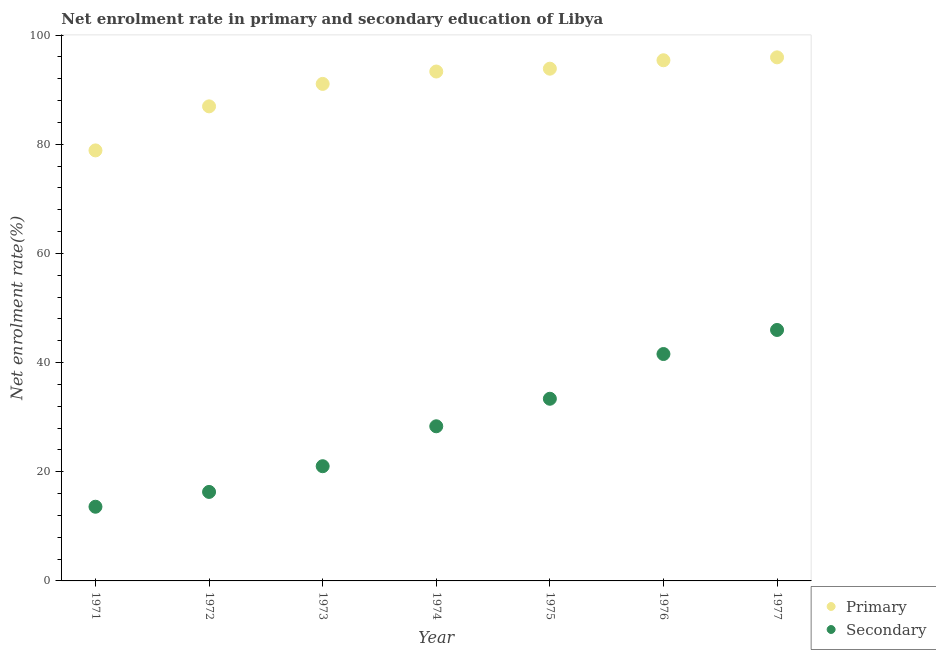How many different coloured dotlines are there?
Your response must be concise. 2. What is the enrollment rate in primary education in 1977?
Make the answer very short. 95.93. Across all years, what is the maximum enrollment rate in primary education?
Ensure brevity in your answer.  95.93. Across all years, what is the minimum enrollment rate in primary education?
Keep it short and to the point. 78.88. What is the total enrollment rate in secondary education in the graph?
Your response must be concise. 200.18. What is the difference between the enrollment rate in primary education in 1971 and that in 1973?
Your answer should be compact. -12.18. What is the difference between the enrollment rate in primary education in 1972 and the enrollment rate in secondary education in 1973?
Provide a succinct answer. 65.94. What is the average enrollment rate in secondary education per year?
Provide a short and direct response. 28.6. In the year 1972, what is the difference between the enrollment rate in secondary education and enrollment rate in primary education?
Offer a terse response. -70.65. What is the ratio of the enrollment rate in primary education in 1973 to that in 1977?
Keep it short and to the point. 0.95. Is the enrollment rate in secondary education in 1971 less than that in 1977?
Make the answer very short. Yes. What is the difference between the highest and the second highest enrollment rate in primary education?
Provide a short and direct response. 0.54. What is the difference between the highest and the lowest enrollment rate in secondary education?
Provide a short and direct response. 32.39. Is the sum of the enrollment rate in secondary education in 1973 and 1977 greater than the maximum enrollment rate in primary education across all years?
Keep it short and to the point. No. Is the enrollment rate in primary education strictly less than the enrollment rate in secondary education over the years?
Your answer should be compact. No. How many dotlines are there?
Your answer should be very brief. 2. Are the values on the major ticks of Y-axis written in scientific E-notation?
Offer a terse response. No. Where does the legend appear in the graph?
Ensure brevity in your answer.  Bottom right. How many legend labels are there?
Your answer should be compact. 2. What is the title of the graph?
Offer a very short reply. Net enrolment rate in primary and secondary education of Libya. Does "Females" appear as one of the legend labels in the graph?
Offer a very short reply. No. What is the label or title of the Y-axis?
Your response must be concise. Net enrolment rate(%). What is the Net enrolment rate(%) in Primary in 1971?
Ensure brevity in your answer.  78.88. What is the Net enrolment rate(%) of Secondary in 1971?
Your response must be concise. 13.59. What is the Net enrolment rate(%) of Primary in 1972?
Your answer should be compact. 86.95. What is the Net enrolment rate(%) in Secondary in 1972?
Offer a very short reply. 16.31. What is the Net enrolment rate(%) of Primary in 1973?
Offer a very short reply. 91.07. What is the Net enrolment rate(%) of Secondary in 1973?
Ensure brevity in your answer.  21.02. What is the Net enrolment rate(%) of Primary in 1974?
Provide a succinct answer. 93.34. What is the Net enrolment rate(%) in Secondary in 1974?
Provide a short and direct response. 28.33. What is the Net enrolment rate(%) of Primary in 1975?
Offer a terse response. 93.86. What is the Net enrolment rate(%) in Secondary in 1975?
Offer a terse response. 33.38. What is the Net enrolment rate(%) in Primary in 1976?
Your answer should be very brief. 95.4. What is the Net enrolment rate(%) in Secondary in 1976?
Keep it short and to the point. 41.57. What is the Net enrolment rate(%) in Primary in 1977?
Offer a very short reply. 95.93. What is the Net enrolment rate(%) of Secondary in 1977?
Offer a terse response. 45.98. Across all years, what is the maximum Net enrolment rate(%) in Primary?
Your answer should be compact. 95.93. Across all years, what is the maximum Net enrolment rate(%) of Secondary?
Offer a terse response. 45.98. Across all years, what is the minimum Net enrolment rate(%) of Primary?
Offer a terse response. 78.88. Across all years, what is the minimum Net enrolment rate(%) in Secondary?
Offer a terse response. 13.59. What is the total Net enrolment rate(%) of Primary in the graph?
Offer a terse response. 635.42. What is the total Net enrolment rate(%) in Secondary in the graph?
Your answer should be compact. 200.18. What is the difference between the Net enrolment rate(%) of Primary in 1971 and that in 1972?
Give a very brief answer. -8.07. What is the difference between the Net enrolment rate(%) in Secondary in 1971 and that in 1972?
Your answer should be compact. -2.71. What is the difference between the Net enrolment rate(%) in Primary in 1971 and that in 1973?
Provide a short and direct response. -12.18. What is the difference between the Net enrolment rate(%) in Secondary in 1971 and that in 1973?
Your answer should be compact. -7.43. What is the difference between the Net enrolment rate(%) of Primary in 1971 and that in 1974?
Your answer should be compact. -14.45. What is the difference between the Net enrolment rate(%) in Secondary in 1971 and that in 1974?
Provide a short and direct response. -14.74. What is the difference between the Net enrolment rate(%) in Primary in 1971 and that in 1975?
Offer a very short reply. -14.97. What is the difference between the Net enrolment rate(%) in Secondary in 1971 and that in 1975?
Your response must be concise. -19.78. What is the difference between the Net enrolment rate(%) in Primary in 1971 and that in 1976?
Make the answer very short. -16.51. What is the difference between the Net enrolment rate(%) of Secondary in 1971 and that in 1976?
Provide a succinct answer. -27.98. What is the difference between the Net enrolment rate(%) of Primary in 1971 and that in 1977?
Make the answer very short. -17.05. What is the difference between the Net enrolment rate(%) of Secondary in 1971 and that in 1977?
Provide a succinct answer. -32.39. What is the difference between the Net enrolment rate(%) in Primary in 1972 and that in 1973?
Keep it short and to the point. -4.11. What is the difference between the Net enrolment rate(%) in Secondary in 1972 and that in 1973?
Provide a short and direct response. -4.71. What is the difference between the Net enrolment rate(%) of Primary in 1972 and that in 1974?
Your answer should be compact. -6.38. What is the difference between the Net enrolment rate(%) of Secondary in 1972 and that in 1974?
Keep it short and to the point. -12.03. What is the difference between the Net enrolment rate(%) of Primary in 1972 and that in 1975?
Offer a very short reply. -6.9. What is the difference between the Net enrolment rate(%) in Secondary in 1972 and that in 1975?
Offer a terse response. -17.07. What is the difference between the Net enrolment rate(%) in Primary in 1972 and that in 1976?
Provide a succinct answer. -8.44. What is the difference between the Net enrolment rate(%) of Secondary in 1972 and that in 1976?
Provide a short and direct response. -25.27. What is the difference between the Net enrolment rate(%) in Primary in 1972 and that in 1977?
Make the answer very short. -8.98. What is the difference between the Net enrolment rate(%) of Secondary in 1972 and that in 1977?
Provide a short and direct response. -29.68. What is the difference between the Net enrolment rate(%) of Primary in 1973 and that in 1974?
Keep it short and to the point. -2.27. What is the difference between the Net enrolment rate(%) of Secondary in 1973 and that in 1974?
Your response must be concise. -7.32. What is the difference between the Net enrolment rate(%) of Primary in 1973 and that in 1975?
Your answer should be very brief. -2.79. What is the difference between the Net enrolment rate(%) of Secondary in 1973 and that in 1975?
Keep it short and to the point. -12.36. What is the difference between the Net enrolment rate(%) in Primary in 1973 and that in 1976?
Offer a terse response. -4.33. What is the difference between the Net enrolment rate(%) of Secondary in 1973 and that in 1976?
Your answer should be very brief. -20.56. What is the difference between the Net enrolment rate(%) in Primary in 1973 and that in 1977?
Offer a very short reply. -4.87. What is the difference between the Net enrolment rate(%) of Secondary in 1973 and that in 1977?
Provide a short and direct response. -24.96. What is the difference between the Net enrolment rate(%) of Primary in 1974 and that in 1975?
Your response must be concise. -0.52. What is the difference between the Net enrolment rate(%) in Secondary in 1974 and that in 1975?
Make the answer very short. -5.04. What is the difference between the Net enrolment rate(%) in Primary in 1974 and that in 1976?
Your answer should be very brief. -2.06. What is the difference between the Net enrolment rate(%) of Secondary in 1974 and that in 1976?
Provide a succinct answer. -13.24. What is the difference between the Net enrolment rate(%) of Primary in 1974 and that in 1977?
Your answer should be very brief. -2.6. What is the difference between the Net enrolment rate(%) in Secondary in 1974 and that in 1977?
Give a very brief answer. -17.65. What is the difference between the Net enrolment rate(%) in Primary in 1975 and that in 1976?
Provide a succinct answer. -1.54. What is the difference between the Net enrolment rate(%) of Secondary in 1975 and that in 1976?
Provide a short and direct response. -8.2. What is the difference between the Net enrolment rate(%) of Primary in 1975 and that in 1977?
Your answer should be very brief. -2.08. What is the difference between the Net enrolment rate(%) of Secondary in 1975 and that in 1977?
Your answer should be very brief. -12.6. What is the difference between the Net enrolment rate(%) of Primary in 1976 and that in 1977?
Offer a very short reply. -0.54. What is the difference between the Net enrolment rate(%) of Secondary in 1976 and that in 1977?
Make the answer very short. -4.41. What is the difference between the Net enrolment rate(%) of Primary in 1971 and the Net enrolment rate(%) of Secondary in 1972?
Provide a succinct answer. 62.58. What is the difference between the Net enrolment rate(%) in Primary in 1971 and the Net enrolment rate(%) in Secondary in 1973?
Provide a succinct answer. 57.87. What is the difference between the Net enrolment rate(%) in Primary in 1971 and the Net enrolment rate(%) in Secondary in 1974?
Your answer should be compact. 50.55. What is the difference between the Net enrolment rate(%) of Primary in 1971 and the Net enrolment rate(%) of Secondary in 1975?
Your answer should be compact. 45.51. What is the difference between the Net enrolment rate(%) in Primary in 1971 and the Net enrolment rate(%) in Secondary in 1976?
Keep it short and to the point. 37.31. What is the difference between the Net enrolment rate(%) of Primary in 1971 and the Net enrolment rate(%) of Secondary in 1977?
Your answer should be very brief. 32.9. What is the difference between the Net enrolment rate(%) in Primary in 1972 and the Net enrolment rate(%) in Secondary in 1973?
Your answer should be very brief. 65.94. What is the difference between the Net enrolment rate(%) in Primary in 1972 and the Net enrolment rate(%) in Secondary in 1974?
Your response must be concise. 58.62. What is the difference between the Net enrolment rate(%) in Primary in 1972 and the Net enrolment rate(%) in Secondary in 1975?
Your answer should be compact. 53.58. What is the difference between the Net enrolment rate(%) in Primary in 1972 and the Net enrolment rate(%) in Secondary in 1976?
Your response must be concise. 45.38. What is the difference between the Net enrolment rate(%) in Primary in 1972 and the Net enrolment rate(%) in Secondary in 1977?
Offer a terse response. 40.97. What is the difference between the Net enrolment rate(%) in Primary in 1973 and the Net enrolment rate(%) in Secondary in 1974?
Offer a terse response. 62.73. What is the difference between the Net enrolment rate(%) in Primary in 1973 and the Net enrolment rate(%) in Secondary in 1975?
Your response must be concise. 57.69. What is the difference between the Net enrolment rate(%) in Primary in 1973 and the Net enrolment rate(%) in Secondary in 1976?
Offer a very short reply. 49.49. What is the difference between the Net enrolment rate(%) of Primary in 1973 and the Net enrolment rate(%) of Secondary in 1977?
Ensure brevity in your answer.  45.08. What is the difference between the Net enrolment rate(%) of Primary in 1974 and the Net enrolment rate(%) of Secondary in 1975?
Provide a succinct answer. 59.96. What is the difference between the Net enrolment rate(%) of Primary in 1974 and the Net enrolment rate(%) of Secondary in 1976?
Your answer should be compact. 51.76. What is the difference between the Net enrolment rate(%) of Primary in 1974 and the Net enrolment rate(%) of Secondary in 1977?
Your answer should be compact. 47.35. What is the difference between the Net enrolment rate(%) in Primary in 1975 and the Net enrolment rate(%) in Secondary in 1976?
Ensure brevity in your answer.  52.28. What is the difference between the Net enrolment rate(%) of Primary in 1975 and the Net enrolment rate(%) of Secondary in 1977?
Provide a succinct answer. 47.87. What is the difference between the Net enrolment rate(%) in Primary in 1976 and the Net enrolment rate(%) in Secondary in 1977?
Give a very brief answer. 49.42. What is the average Net enrolment rate(%) of Primary per year?
Your response must be concise. 90.77. What is the average Net enrolment rate(%) of Secondary per year?
Offer a very short reply. 28.6. In the year 1971, what is the difference between the Net enrolment rate(%) of Primary and Net enrolment rate(%) of Secondary?
Offer a terse response. 65.29. In the year 1972, what is the difference between the Net enrolment rate(%) of Primary and Net enrolment rate(%) of Secondary?
Keep it short and to the point. 70.65. In the year 1973, what is the difference between the Net enrolment rate(%) in Primary and Net enrolment rate(%) in Secondary?
Offer a very short reply. 70.05. In the year 1974, what is the difference between the Net enrolment rate(%) of Primary and Net enrolment rate(%) of Secondary?
Your response must be concise. 65. In the year 1975, what is the difference between the Net enrolment rate(%) of Primary and Net enrolment rate(%) of Secondary?
Your response must be concise. 60.48. In the year 1976, what is the difference between the Net enrolment rate(%) in Primary and Net enrolment rate(%) in Secondary?
Provide a short and direct response. 53.82. In the year 1977, what is the difference between the Net enrolment rate(%) in Primary and Net enrolment rate(%) in Secondary?
Ensure brevity in your answer.  49.95. What is the ratio of the Net enrolment rate(%) of Primary in 1971 to that in 1972?
Offer a very short reply. 0.91. What is the ratio of the Net enrolment rate(%) of Secondary in 1971 to that in 1972?
Offer a terse response. 0.83. What is the ratio of the Net enrolment rate(%) in Primary in 1971 to that in 1973?
Provide a succinct answer. 0.87. What is the ratio of the Net enrolment rate(%) in Secondary in 1971 to that in 1973?
Provide a short and direct response. 0.65. What is the ratio of the Net enrolment rate(%) of Primary in 1971 to that in 1974?
Provide a short and direct response. 0.85. What is the ratio of the Net enrolment rate(%) in Secondary in 1971 to that in 1974?
Your answer should be compact. 0.48. What is the ratio of the Net enrolment rate(%) in Primary in 1971 to that in 1975?
Make the answer very short. 0.84. What is the ratio of the Net enrolment rate(%) in Secondary in 1971 to that in 1975?
Provide a succinct answer. 0.41. What is the ratio of the Net enrolment rate(%) of Primary in 1971 to that in 1976?
Ensure brevity in your answer.  0.83. What is the ratio of the Net enrolment rate(%) of Secondary in 1971 to that in 1976?
Make the answer very short. 0.33. What is the ratio of the Net enrolment rate(%) of Primary in 1971 to that in 1977?
Make the answer very short. 0.82. What is the ratio of the Net enrolment rate(%) in Secondary in 1971 to that in 1977?
Your answer should be compact. 0.3. What is the ratio of the Net enrolment rate(%) in Primary in 1972 to that in 1973?
Your answer should be compact. 0.95. What is the ratio of the Net enrolment rate(%) in Secondary in 1972 to that in 1973?
Keep it short and to the point. 0.78. What is the ratio of the Net enrolment rate(%) in Primary in 1972 to that in 1974?
Provide a succinct answer. 0.93. What is the ratio of the Net enrolment rate(%) in Secondary in 1972 to that in 1974?
Make the answer very short. 0.58. What is the ratio of the Net enrolment rate(%) in Primary in 1972 to that in 1975?
Your response must be concise. 0.93. What is the ratio of the Net enrolment rate(%) in Secondary in 1972 to that in 1975?
Your answer should be compact. 0.49. What is the ratio of the Net enrolment rate(%) of Primary in 1972 to that in 1976?
Give a very brief answer. 0.91. What is the ratio of the Net enrolment rate(%) of Secondary in 1972 to that in 1976?
Keep it short and to the point. 0.39. What is the ratio of the Net enrolment rate(%) of Primary in 1972 to that in 1977?
Provide a succinct answer. 0.91. What is the ratio of the Net enrolment rate(%) in Secondary in 1972 to that in 1977?
Keep it short and to the point. 0.35. What is the ratio of the Net enrolment rate(%) in Primary in 1973 to that in 1974?
Offer a very short reply. 0.98. What is the ratio of the Net enrolment rate(%) in Secondary in 1973 to that in 1974?
Your response must be concise. 0.74. What is the ratio of the Net enrolment rate(%) of Primary in 1973 to that in 1975?
Your answer should be compact. 0.97. What is the ratio of the Net enrolment rate(%) in Secondary in 1973 to that in 1975?
Provide a succinct answer. 0.63. What is the ratio of the Net enrolment rate(%) of Primary in 1973 to that in 1976?
Your answer should be compact. 0.95. What is the ratio of the Net enrolment rate(%) of Secondary in 1973 to that in 1976?
Offer a terse response. 0.51. What is the ratio of the Net enrolment rate(%) of Primary in 1973 to that in 1977?
Your answer should be compact. 0.95. What is the ratio of the Net enrolment rate(%) in Secondary in 1973 to that in 1977?
Offer a very short reply. 0.46. What is the ratio of the Net enrolment rate(%) of Primary in 1974 to that in 1975?
Your answer should be very brief. 0.99. What is the ratio of the Net enrolment rate(%) in Secondary in 1974 to that in 1975?
Your answer should be compact. 0.85. What is the ratio of the Net enrolment rate(%) in Primary in 1974 to that in 1976?
Ensure brevity in your answer.  0.98. What is the ratio of the Net enrolment rate(%) of Secondary in 1974 to that in 1976?
Your response must be concise. 0.68. What is the ratio of the Net enrolment rate(%) of Primary in 1974 to that in 1977?
Your answer should be compact. 0.97. What is the ratio of the Net enrolment rate(%) of Secondary in 1974 to that in 1977?
Provide a succinct answer. 0.62. What is the ratio of the Net enrolment rate(%) of Primary in 1975 to that in 1976?
Give a very brief answer. 0.98. What is the ratio of the Net enrolment rate(%) of Secondary in 1975 to that in 1976?
Offer a very short reply. 0.8. What is the ratio of the Net enrolment rate(%) of Primary in 1975 to that in 1977?
Offer a very short reply. 0.98. What is the ratio of the Net enrolment rate(%) in Secondary in 1975 to that in 1977?
Make the answer very short. 0.73. What is the ratio of the Net enrolment rate(%) in Secondary in 1976 to that in 1977?
Offer a terse response. 0.9. What is the difference between the highest and the second highest Net enrolment rate(%) of Primary?
Your answer should be compact. 0.54. What is the difference between the highest and the second highest Net enrolment rate(%) in Secondary?
Keep it short and to the point. 4.41. What is the difference between the highest and the lowest Net enrolment rate(%) of Primary?
Offer a terse response. 17.05. What is the difference between the highest and the lowest Net enrolment rate(%) of Secondary?
Offer a terse response. 32.39. 